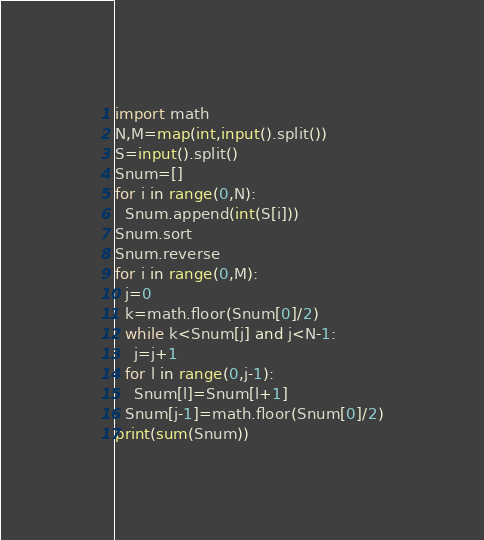Convert code to text. <code><loc_0><loc_0><loc_500><loc_500><_Python_>import math
N,M=map(int,input().split())
S=input().split()
Snum=[]
for i in range(0,N):
  Snum.append(int(S[i]))
Snum.sort
Snum.reverse
for i in range(0,M):
  j=0
  k=math.floor(Snum[0]/2)
  while k<Snum[j] and j<N-1:
    j=j+1
  for l in range(0,j-1):
    Snum[l]=Snum[l+1]
  Snum[j-1]=math.floor(Snum[0]/2)
print(sum(Snum))</code> 